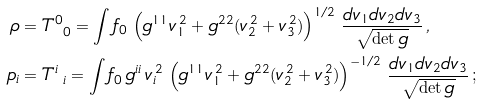<formula> <loc_0><loc_0><loc_500><loc_500>\rho & = T ^ { 0 } _ { \ 0 } = \int f _ { 0 } \, \left ( g ^ { 1 1 } v _ { 1 } ^ { \, 2 } + g ^ { 2 2 } ( v _ { 2 } ^ { \, 2 } + v _ { 3 } ^ { \, 2 } ) \right ) ^ { 1 / 2 } \, \frac { d v _ { 1 } d v _ { 2 } d v _ { 3 } } { \sqrt { \det g } } \, , \\ p _ { i } & = T ^ { i } _ { \ i } = \int f _ { 0 } \, g ^ { i i } \, v _ { i } ^ { \, 2 } \, \left ( g ^ { 1 1 } v _ { 1 } ^ { \, 2 } + g ^ { 2 2 } ( v _ { 2 } ^ { \, 2 } + v _ { 3 } ^ { \, 2 } ) \right ) ^ { - 1 / 2 } \, \frac { d v _ { 1 } d v _ { 2 } d v _ { 3 } } { \sqrt { \det g } } \, ;</formula> 